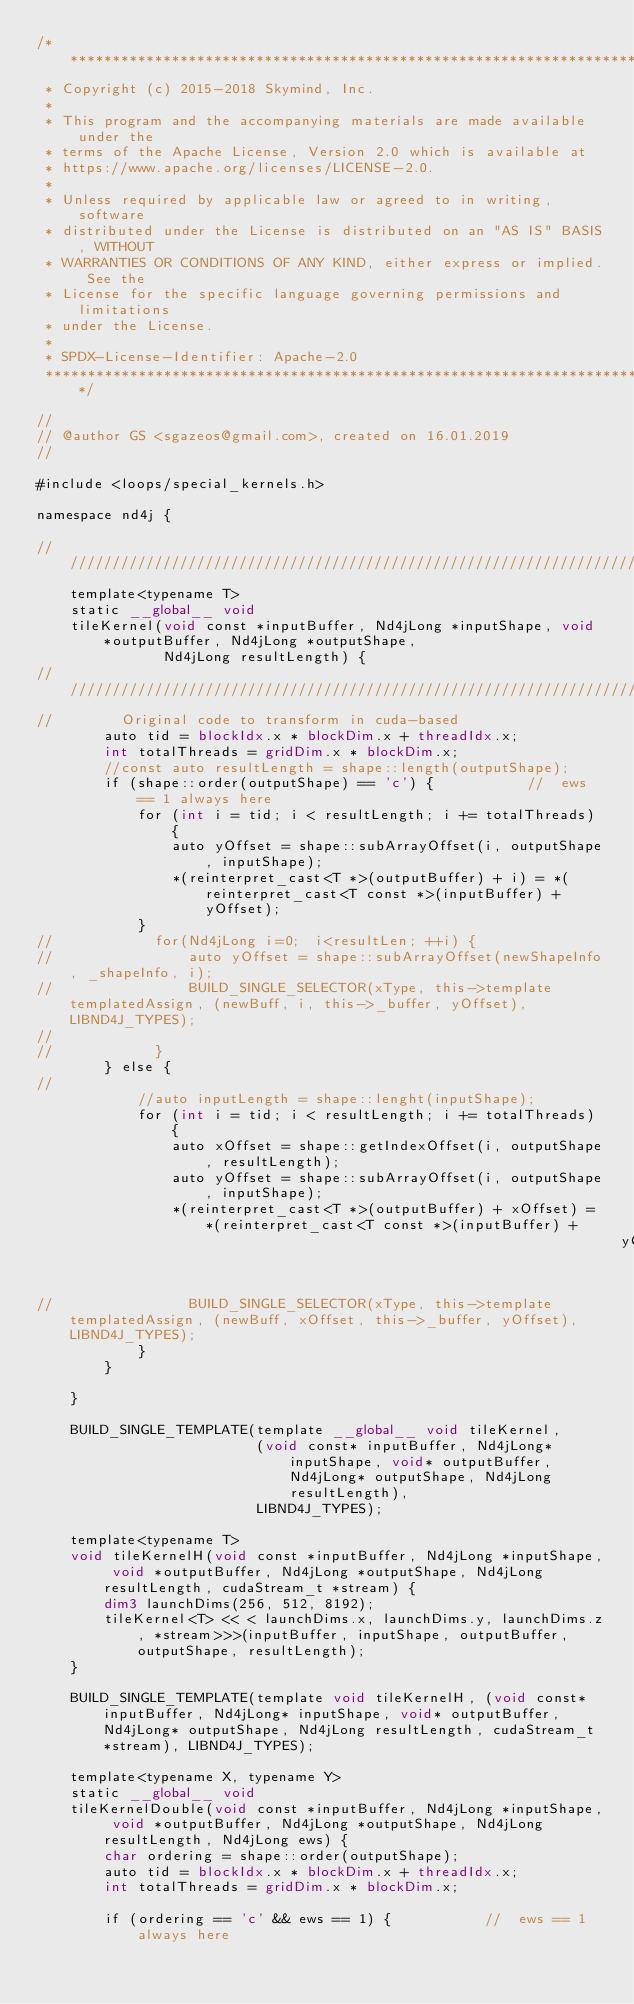<code> <loc_0><loc_0><loc_500><loc_500><_Cuda_>/*******************************************************************************
 * Copyright (c) 2015-2018 Skymind, Inc.
 *
 * This program and the accompanying materials are made available under the
 * terms of the Apache License, Version 2.0 which is available at
 * https://www.apache.org/licenses/LICENSE-2.0.
 *
 * Unless required by applicable law or agreed to in writing, software
 * distributed under the License is distributed on an "AS IS" BASIS, WITHOUT
 * WARRANTIES OR CONDITIONS OF ANY KIND, either express or implied. See the
 * License for the specific language governing permissions and limitations
 * under the License.
 *
 * SPDX-License-Identifier: Apache-2.0
 ******************************************************************************/

//
// @author GS <sgazeos@gmail.com>, created on 16.01.2019
//

#include <loops/special_kernels.h>

namespace nd4j {

////////////////////////////////////////////////////////////////////////
    template<typename T>
    static __global__ void
    tileKernel(void const *inputBuffer, Nd4jLong *inputShape, void *outputBuffer, Nd4jLong *outputShape,
               Nd4jLong resultLength) {
////////////////////////////////////////////////////////////////////////////////////////////////////////////////////////
//        Original code to transform in cuda-based
        auto tid = blockIdx.x * blockDim.x + threadIdx.x;
        int totalThreads = gridDim.x * blockDim.x;
        //const auto resultLength = shape::length(outputShape);
        if (shape::order(outputShape) == 'c') {           //  ews == 1 always here
            for (int i = tid; i < resultLength; i += totalThreads) {
                auto yOffset = shape::subArrayOffset(i, outputShape, inputShape);
                *(reinterpret_cast<T *>(outputBuffer) + i) = *(reinterpret_cast<T const *>(inputBuffer) + yOffset);
            }
//            for(Nd4jLong i=0;  i<resultLen; ++i) {
//                auto yOffset = shape::subArrayOffset(newShapeInfo, _shapeInfo, i);
//                BUILD_SINGLE_SELECTOR(xType, this->template templatedAssign, (newBuff, i, this->_buffer, yOffset), LIBND4J_TYPES);
//
//            }
        } else {
//
            //auto inputLength = shape::lenght(inputShape);
            for (int i = tid; i < resultLength; i += totalThreads) {
                auto xOffset = shape::getIndexOffset(i, outputShape, resultLength);
                auto yOffset = shape::subArrayOffset(i, outputShape, inputShape);
                *(reinterpret_cast<T *>(outputBuffer) + xOffset) = *(reinterpret_cast<T const *>(inputBuffer) +
                                                                     yOffset);
//                BUILD_SINGLE_SELECTOR(xType, this->template templatedAssign, (newBuff, xOffset, this->_buffer, yOffset), LIBND4J_TYPES);
            }
        }

    }

    BUILD_SINGLE_TEMPLATE(template __global__ void tileKernel,
                          (void const* inputBuffer, Nd4jLong* inputShape, void* outputBuffer, Nd4jLong* outputShape, Nd4jLong resultLength),
                          LIBND4J_TYPES);

    template<typename T>
    void tileKernelH(void const *inputBuffer, Nd4jLong *inputShape, void *outputBuffer, Nd4jLong *outputShape, Nd4jLong resultLength, cudaStream_t *stream) {
        dim3 launchDims(256, 512, 8192);
        tileKernel<T> << < launchDims.x, launchDims.y, launchDims.z, *stream>>>(inputBuffer, inputShape, outputBuffer, outputShape, resultLength);
    }

    BUILD_SINGLE_TEMPLATE(template void tileKernelH, (void const* inputBuffer, Nd4jLong* inputShape, void* outputBuffer, Nd4jLong* outputShape, Nd4jLong resultLength, cudaStream_t *stream), LIBND4J_TYPES);

    template<typename X, typename Y>
    static __global__ void
    tileKernelDouble(void const *inputBuffer, Nd4jLong *inputShape, void *outputBuffer, Nd4jLong *outputShape, Nd4jLong resultLength, Nd4jLong ews) {
        char ordering = shape::order(outputShape);
        auto tid = blockIdx.x * blockDim.x + threadIdx.x;
        int totalThreads = gridDim.x * blockDim.x;

        if (ordering == 'c' && ews == 1) {           //  ews == 1 always here</code> 